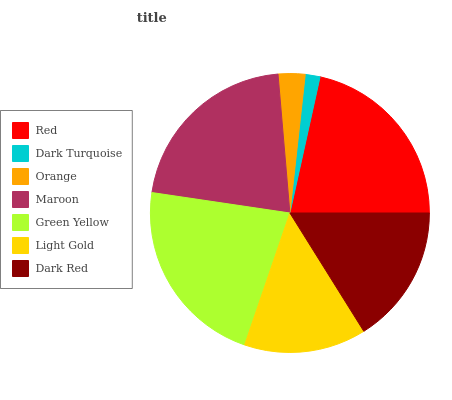Is Dark Turquoise the minimum?
Answer yes or no. Yes. Is Green Yellow the maximum?
Answer yes or no. Yes. Is Orange the minimum?
Answer yes or no. No. Is Orange the maximum?
Answer yes or no. No. Is Orange greater than Dark Turquoise?
Answer yes or no. Yes. Is Dark Turquoise less than Orange?
Answer yes or no. Yes. Is Dark Turquoise greater than Orange?
Answer yes or no. No. Is Orange less than Dark Turquoise?
Answer yes or no. No. Is Dark Red the high median?
Answer yes or no. Yes. Is Dark Red the low median?
Answer yes or no. Yes. Is Dark Turquoise the high median?
Answer yes or no. No. Is Green Yellow the low median?
Answer yes or no. No. 